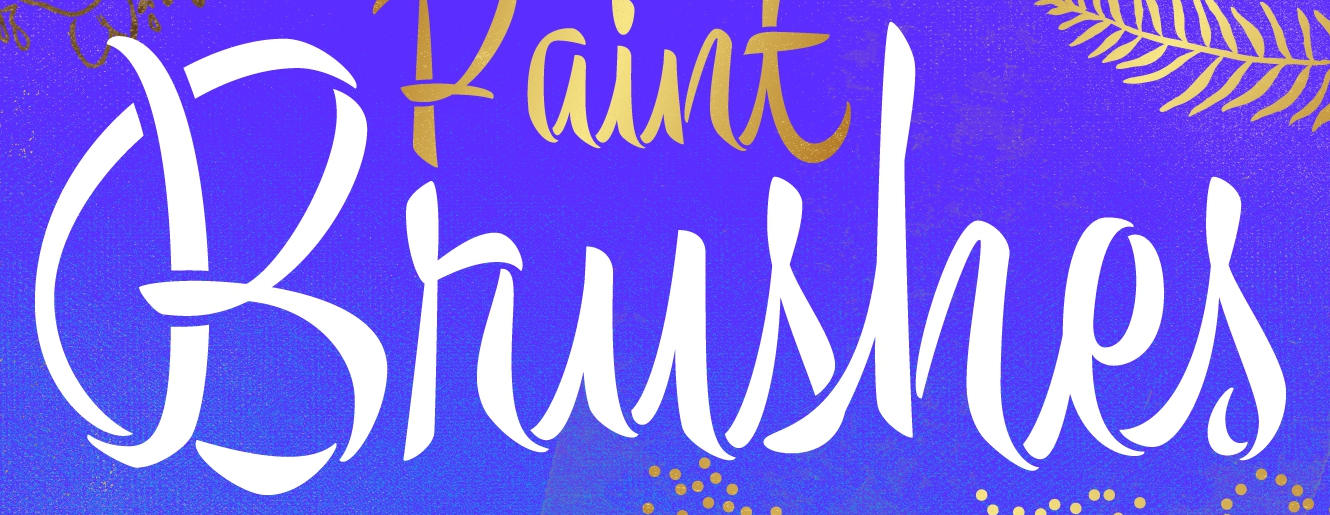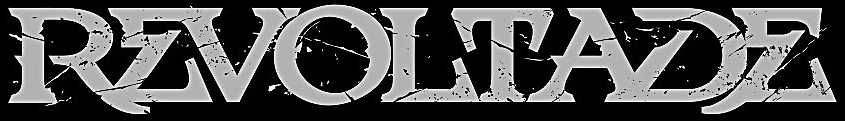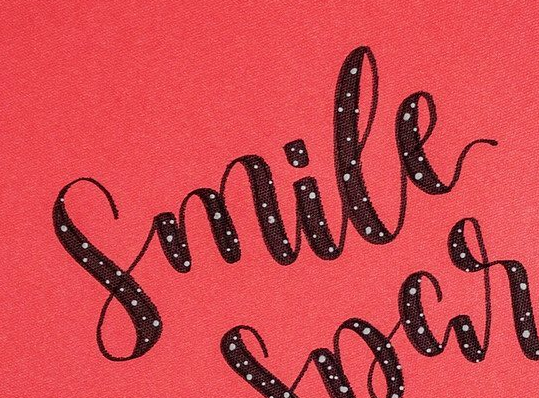What text appears in these images from left to right, separated by a semicolon? Brushes; REVOLTADE; Smile 